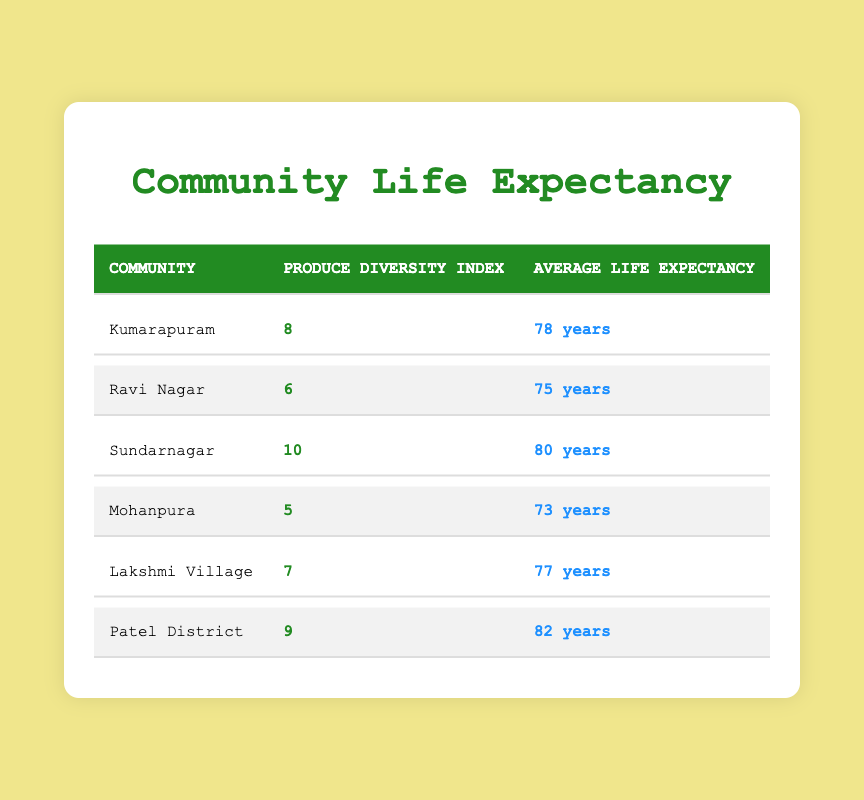What is the average life expectancy of the communities listed? To find the average, we sum the life expectancies of all communities: 78 + 75 + 80 + 73 + 77 + 82 = 465. There are 6 communities, so the average life expectancy is 465 / 6 ≈ 77.5 years.
Answer: 77.5 years Which community has the highest produce diversity index? By examining the produce diversity index, the highest value is 10, which belongs to Sundarnagar.
Answer: Sundarnagar Is it true that communities with a higher produce diversity index tend to have a higher life expectancy? We can compare the produce diversity index and life expectancy across communities. Patel District (9, 82), Sundarnagar (10, 80), and Kumarapuram (8, 78) show this trend, while Mohanpura (5, 73) does not. This indicates a general correlation, making the statement true overall.
Answer: Yes What is the produce diversity index of Lakshmi Village? The table shows that the produce diversity index for Lakshmi Village is 7.
Answer: 7 What is the difference in life expectancy between the community with the highest and the lowest produce diversity index? Sundarnagar has the highest index (10) and an average life expectancy of 80 years, while Mohanpura has the lowest index (5) with an expectancy of 73 years. The difference is 80 - 73 = 7 years.
Answer: 7 years How many communities have an average life expectancy greater than 77 years? Checking the values, we find Patel District (82), Sundarnagar (80), and Kumarapuram (78) have life expectancies greater than 77. Therefore, 3 communities fit this criterion.
Answer: 3 What is the sum of the produce diversity indexes for communities with a life expectancy over 75 years? The communities with over 75 years are Kumarapuram (8), Sundarnagar (10), Lakshmi Village (7), and Patel District (9). Their produce diversity indexes sum to 8 + 10 + 7 + 9 = 34.
Answer: 34 Which community has a life expectancy of 75 years? Looking at the table, Ravi Nagar is listed with an average life expectancy of 75 years.
Answer: Ravi Nagar 